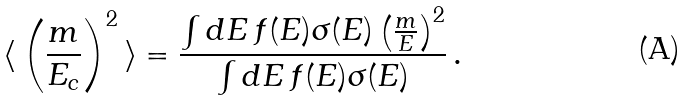Convert formula to latex. <formula><loc_0><loc_0><loc_500><loc_500>\langle \, \left ( \frac { m } { E _ { c } } \right ) ^ { 2 } \, \rangle = \frac { \int d E \, f ( E ) \sigma ( E ) \left ( \frac { m } { E } \right ) ^ { 2 } } { \int d E \, f ( E ) \sigma ( E ) } \, .</formula> 